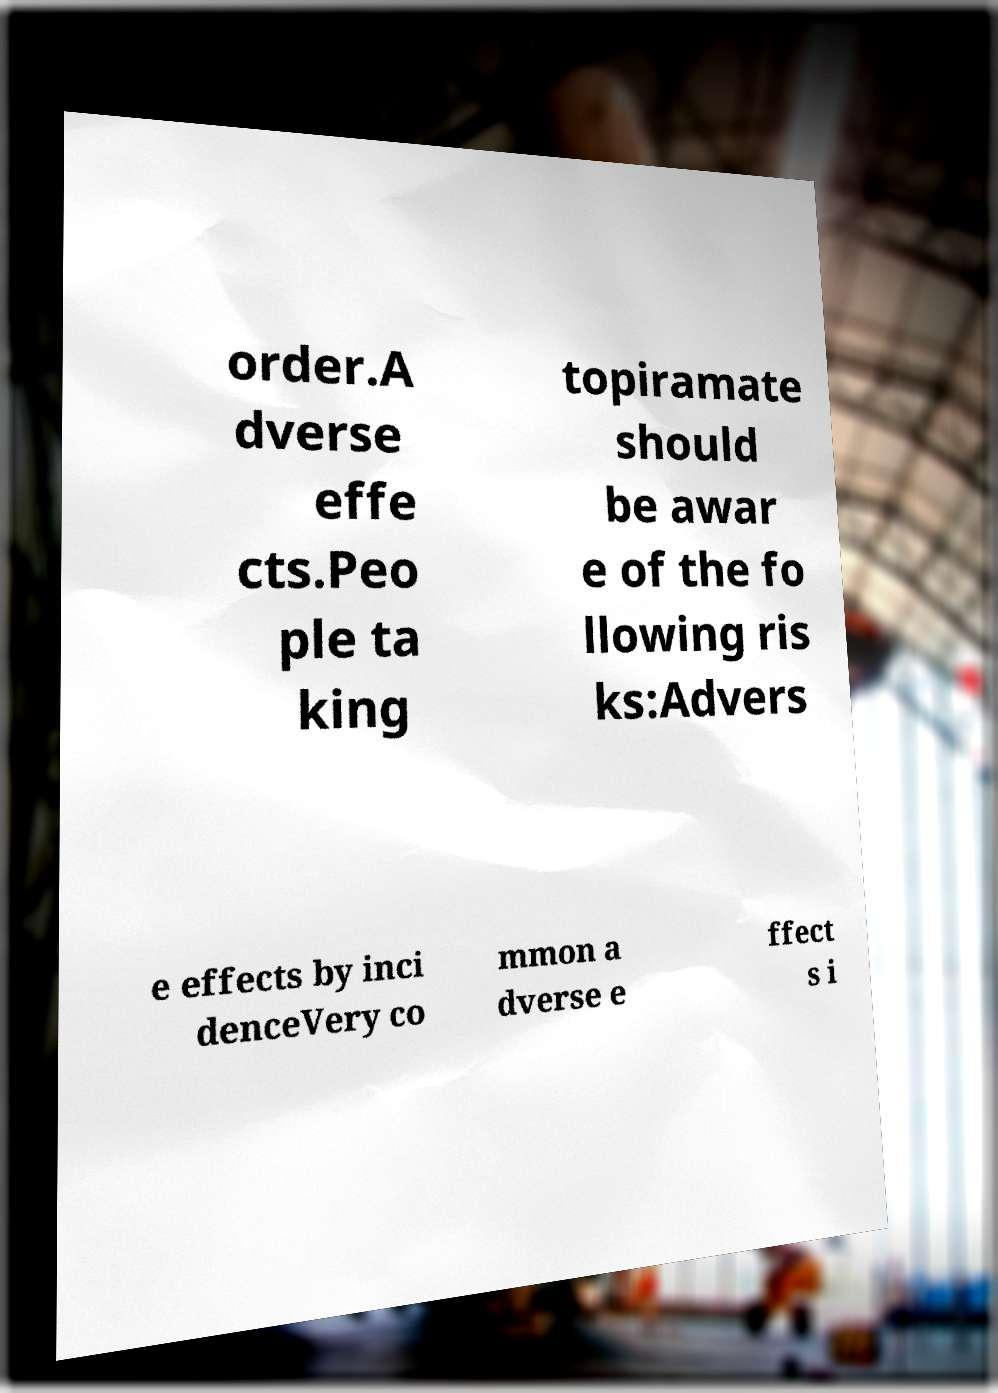I need the written content from this picture converted into text. Can you do that? order.A dverse effe cts.Peo ple ta king topiramate should be awar e of the fo llowing ris ks:Advers e effects by inci denceVery co mmon a dverse e ffect s i 